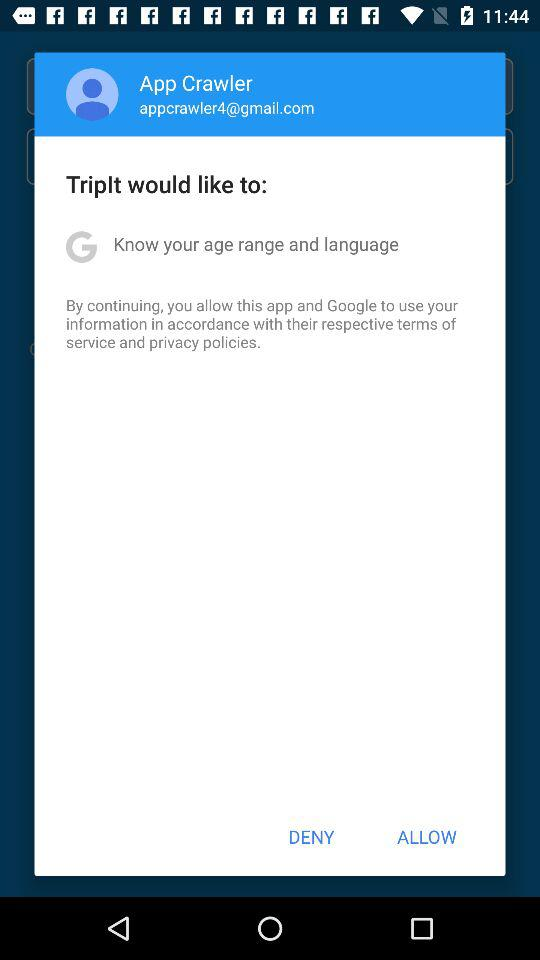What is the name of the user? The name of the user is App Crawler. 